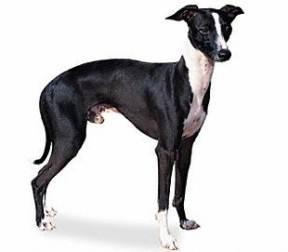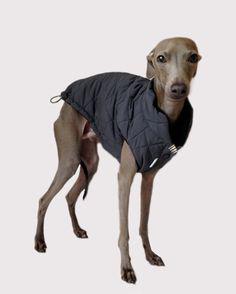The first image is the image on the left, the second image is the image on the right. Assess this claim about the two images: "At least one of the dogs is wearing something on its feet.". Correct or not? Answer yes or no. No. 